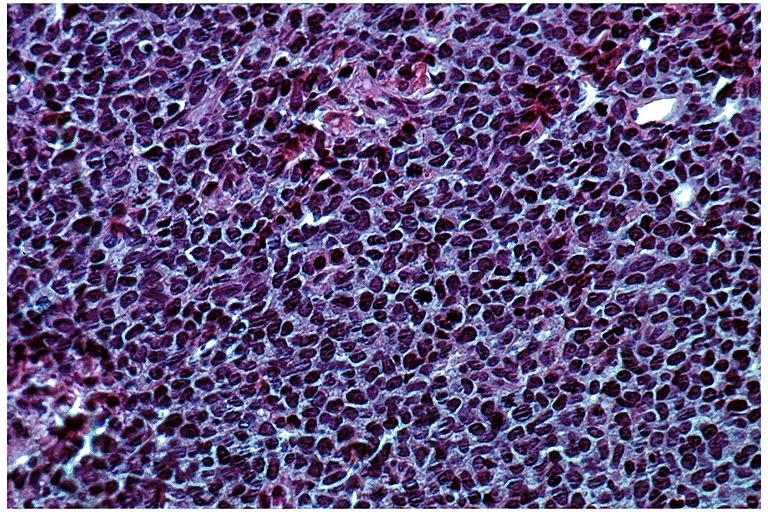what is present?
Answer the question using a single word or phrase. Oral 